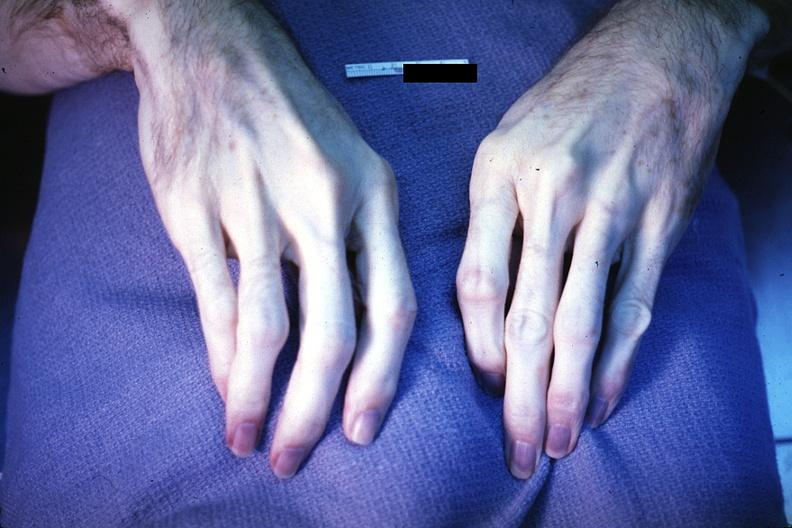what are present?
Answer the question using a single word or phrase. Extremities 